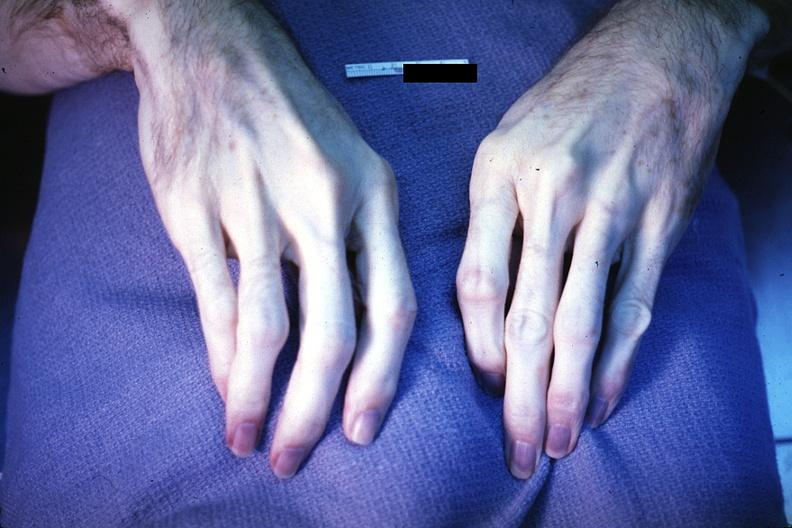what are present?
Answer the question using a single word or phrase. Extremities 